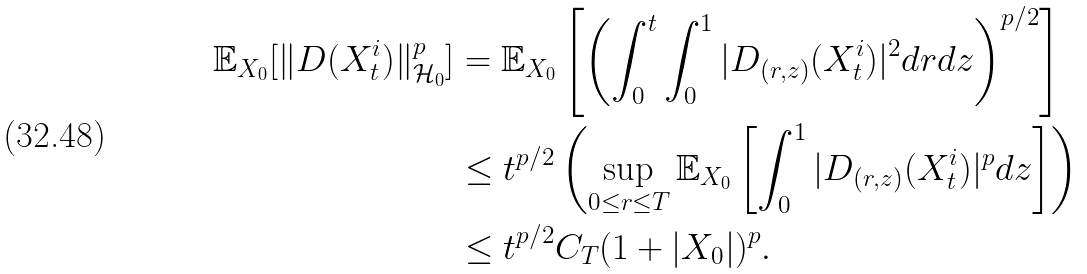Convert formula to latex. <formula><loc_0><loc_0><loc_500><loc_500>\mathbb { E } _ { X _ { 0 } } [ \| D ( X _ { t } ^ { i } ) \| ^ { p } _ { \mathcal { H } _ { 0 } } ] & = \mathbb { E } _ { X _ { 0 } } \left [ \left ( \int _ { 0 } ^ { t } \int _ { 0 } ^ { 1 } | D _ { ( r , z ) } ( X _ { t } ^ { i } ) | ^ { 2 } d r d z \right ) ^ { p / 2 } \right ] \\ & \leq t ^ { p / 2 } \left ( \sup _ { 0 \leq r \leq T } \mathbb { E } _ { X _ { 0 } } \left [ \int _ { 0 } ^ { 1 } | D _ { ( r , z ) } ( X _ { t } ^ { i } ) | ^ { p } d z \right ] \right ) \\ & \leq t ^ { p / 2 } C _ { T } ( 1 + | X _ { 0 } | ) ^ { p } .</formula> 